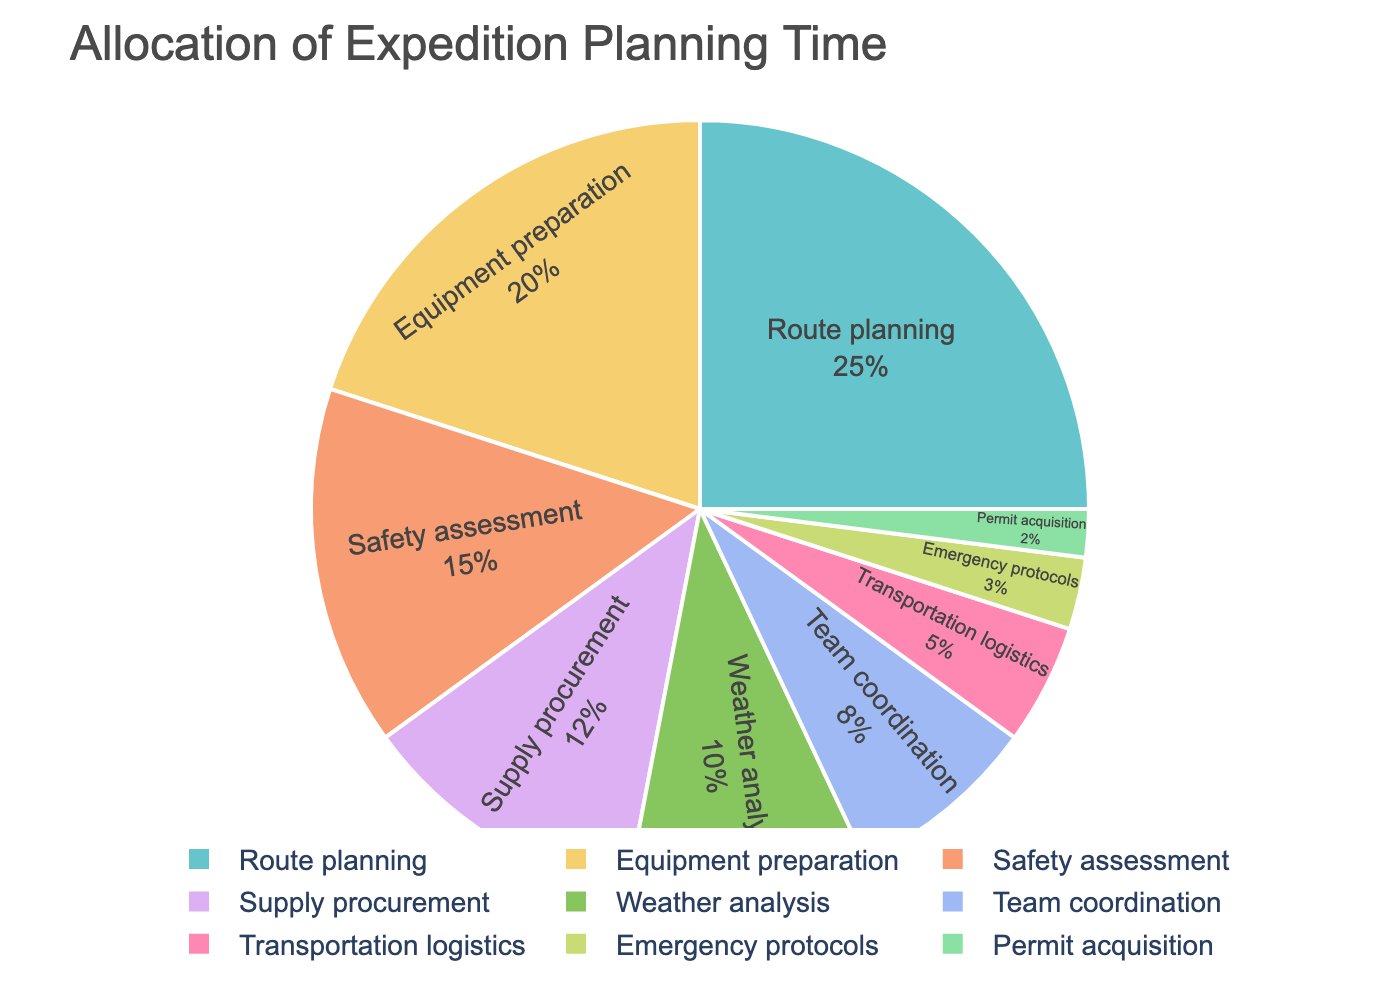What percentage of the total planning time is allocated to route planning and equipment preparation combined? To find the combined percentage, sum the percentages of route planning and equipment preparation: 25% (route planning) + 20% (equipment preparation).
Answer: 45% Which task takes up more time, weather analysis or team coordination? Compare the percentages of both tasks: weather analysis (10%) and team coordination (8%). Since 10% is greater than 8%, weather analysis takes up more time.
Answer: Weather analysis How does the time allocated for safety assessment compare to supply procurement? Compare the percentages: safety assessment has 15%, and supply procurement has 12%. Since 15% is greater than 12%, more time is allocated to safety assessment.
Answer: Safety assessment What is the smallest percentage among all the tasks? Identify the smallest percentage from all tasks: Permit acquisition has the smallest percentage at 2%.
Answer: Permit acquisition If we combine the time spent on emergency protocols and transportation logistics, does it exceed the time allocated for supply procurement? Sum the percentages of emergency protocols and transportation logistics: 3% + 5% = 8%. Compare it to supply procurement, which is 12%. Since 8% is less than 12%, it does not exceed the time allocated for supply procurement.
Answer: No What tasks together make up 50% of the planning time? Identify the tasks that together sum up to 50% or closer to 50% to match the given percentages: Route planning (25%) + Equipment preparation (20%) + Safety assessment (15%) = 60%. Thus, Route planning and Equipment preparation add up to 45%, which is the closest to 50%.
Answer: Route planning, Equipment preparation How much more planning time is devoted to route planning as compared to weather analysis? Subtract the percentage of weather analysis from route planning: 25% (route planning) - 10% (weather analysis) = 15%.
Answer: 15% Which has a higher percentage, the combined time for permit acquisition, emergency protocols, and transportation logistics, or the time allocated for safety assessment? Sum the percentages for permit acquisition, emergency protocols, and transportation logistics: 2% + 3% + 5% = 10%. Compare it to safety assessment, which is 15%. Since 15% is greater than 10%, safety assessment has a higher percentage.
Answer: Safety assessment What is the combined percentage of the tasks that each take up less than 10% of the planning time? Sum the percentages of tasks with less than 10%: Transportation logistics (5%), Emergency protocols (3%), Permit acquisition (2%). Therefore, 5% + 3% + 2% = 10%.
Answer: 10% 